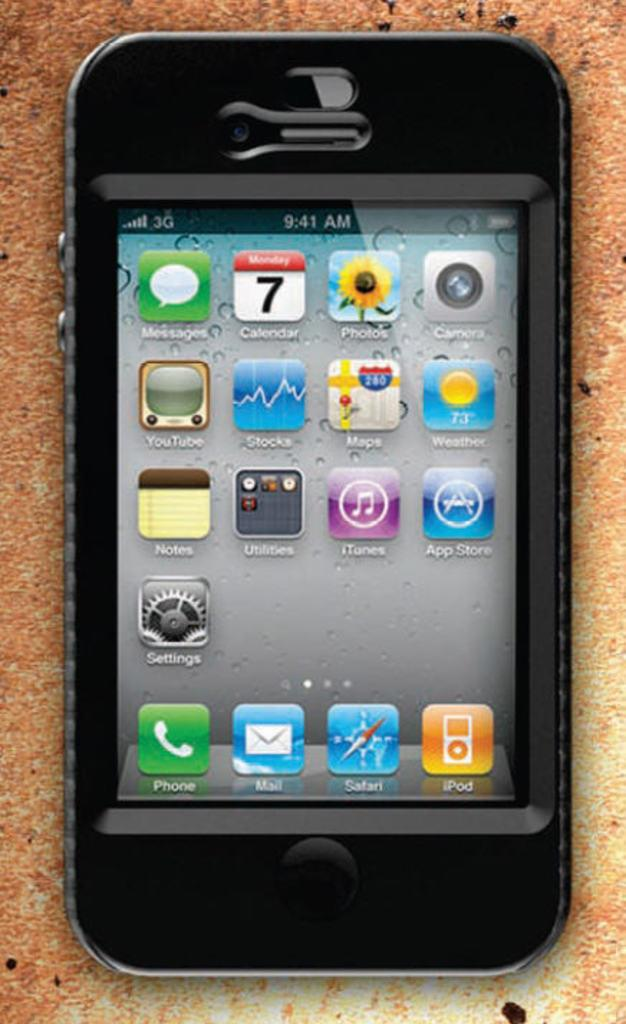<image>
Write a terse but informative summary of the picture. A smart phone open to a page of apps showing it to be 9:41 am. 